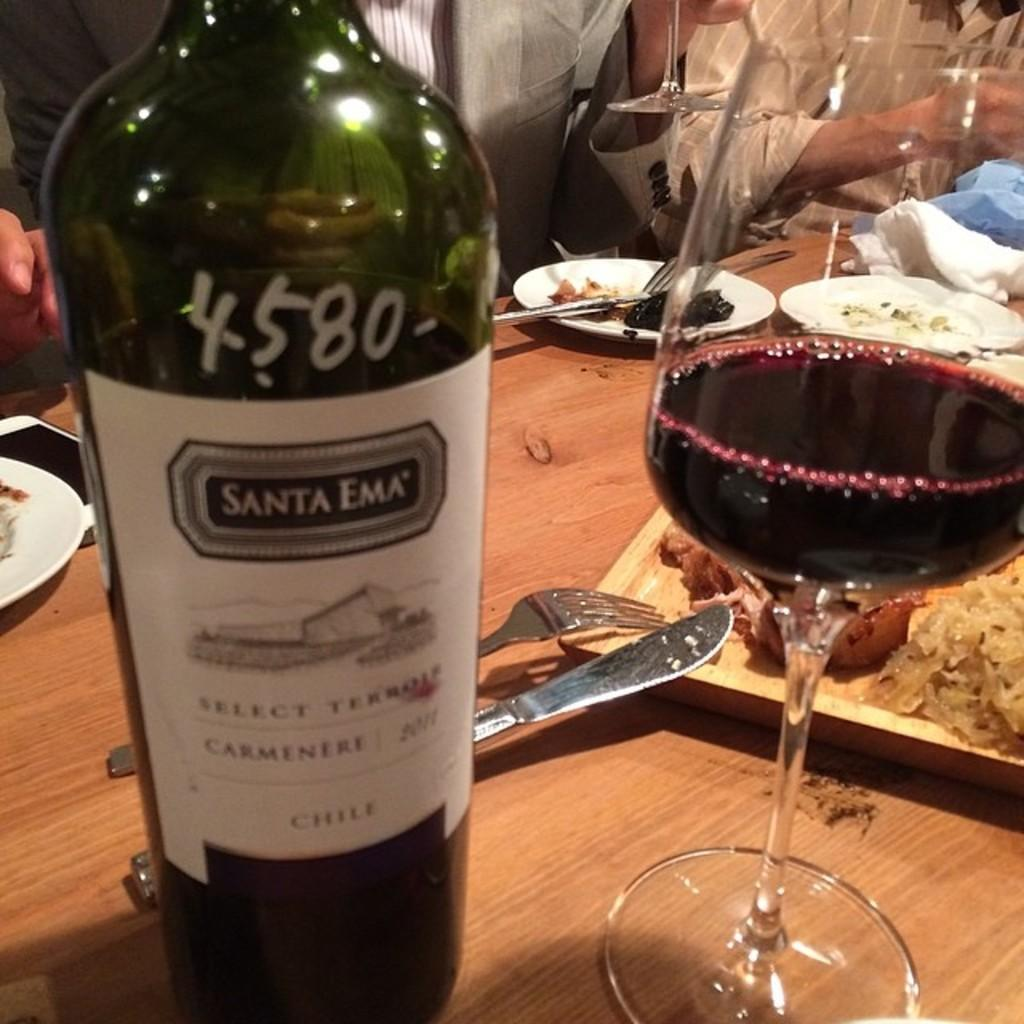Provide a one-sentence caption for the provided image. A bottle of Santa Ema with 4580 written on it. 